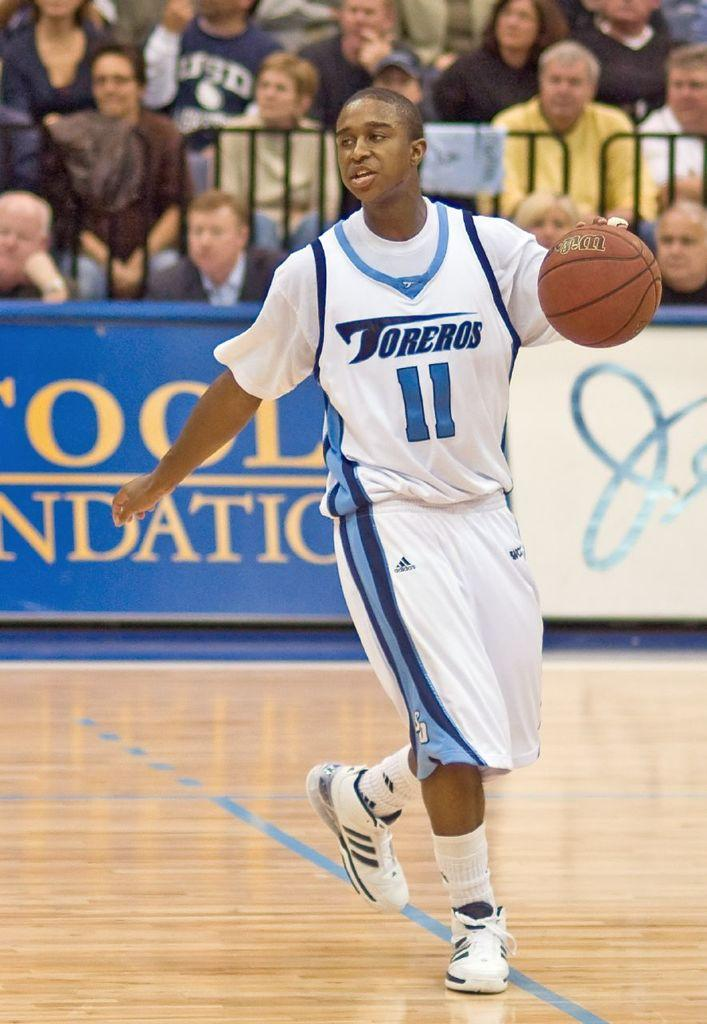<image>
Write a terse but informative summary of the picture. A man with the number 11 on his jersey is dribbling a basketball. 